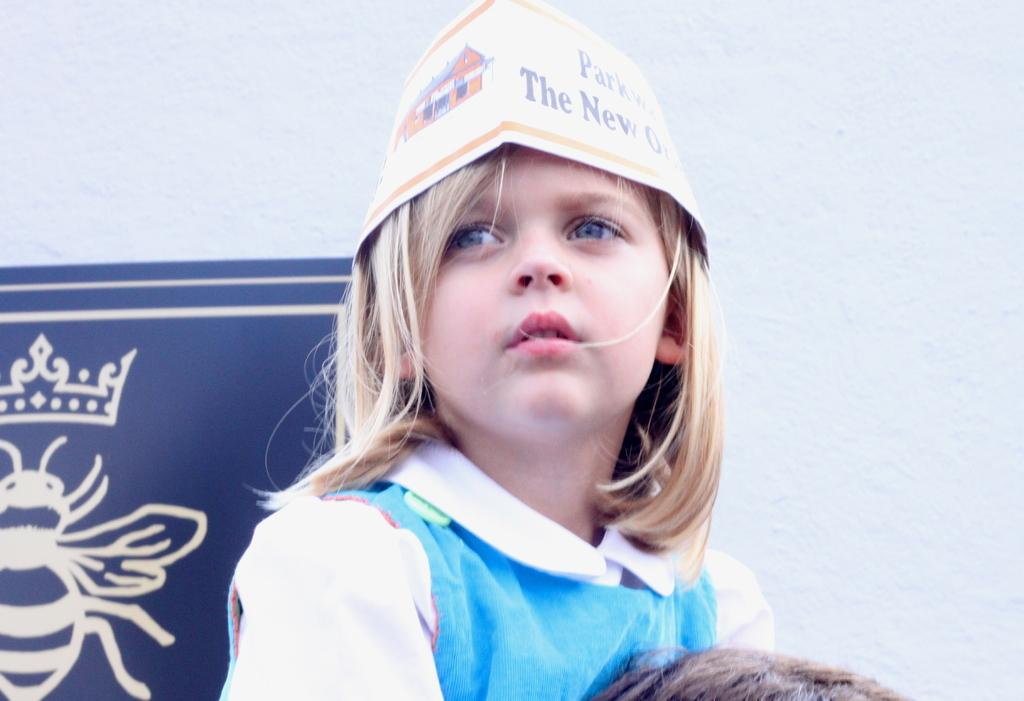<image>
Describe the image concisely. A young, blonde girl wears a paper hat, with the partial text Park the New O on one side and a sketch of a house on the other side. 